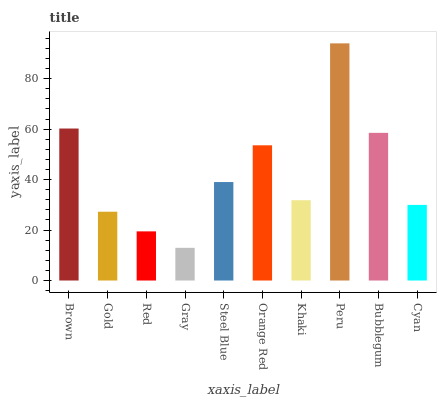Is Gray the minimum?
Answer yes or no. Yes. Is Peru the maximum?
Answer yes or no. Yes. Is Gold the minimum?
Answer yes or no. No. Is Gold the maximum?
Answer yes or no. No. Is Brown greater than Gold?
Answer yes or no. Yes. Is Gold less than Brown?
Answer yes or no. Yes. Is Gold greater than Brown?
Answer yes or no. No. Is Brown less than Gold?
Answer yes or no. No. Is Steel Blue the high median?
Answer yes or no. Yes. Is Khaki the low median?
Answer yes or no. Yes. Is Gold the high median?
Answer yes or no. No. Is Bubblegum the low median?
Answer yes or no. No. 